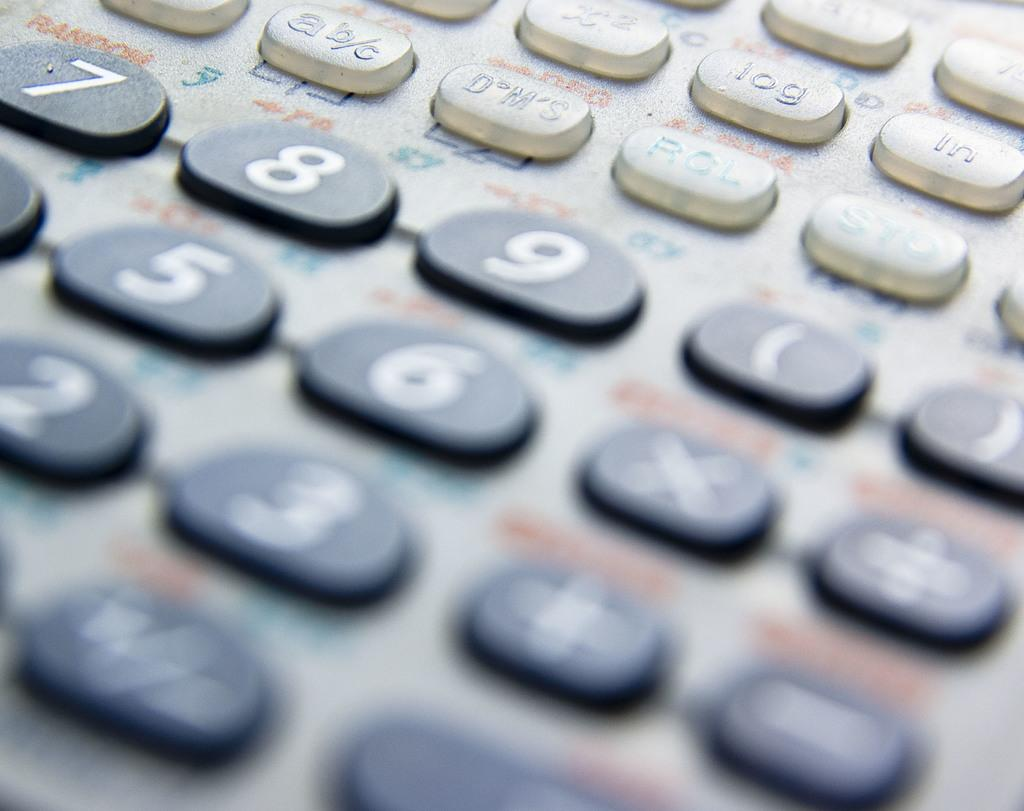<image>
Describe the image concisely. the number 6 is on the black keyboard with many numbers 